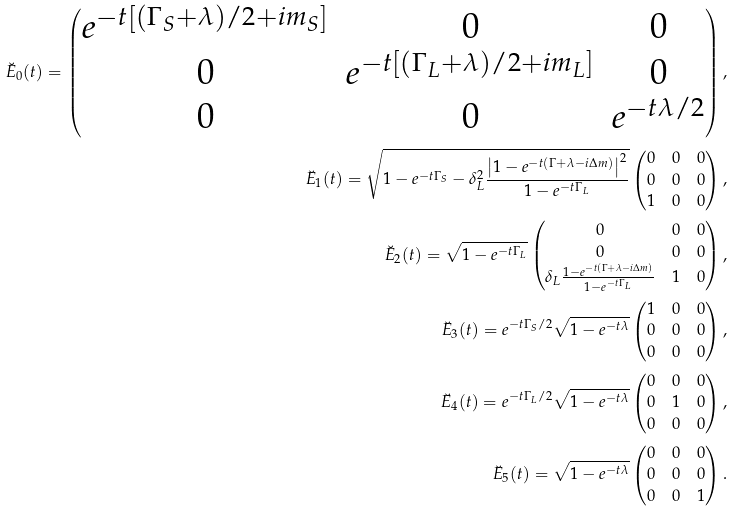Convert formula to latex. <formula><loc_0><loc_0><loc_500><loc_500>\breve { E } _ { 0 } ( t ) = \begin{pmatrix} e ^ { - t \left [ ( \Gamma _ { S } + \lambda ) / 2 + i m _ { S } \right ] } & 0 & 0 \\ 0 & e ^ { - t \left [ ( \Gamma _ { L } + \lambda ) / 2 + i m _ { L } \right ] } & 0 \\ 0 & 0 & e ^ { - t \lambda / 2 } \end{pmatrix} , \\ \breve { E } _ { 1 } ( t ) = \sqrt { 1 - e ^ { - t \Gamma _ { S } } - \delta _ { L } ^ { 2 } \frac { \left | 1 - e ^ { - t ( \Gamma + \lambda - i \Delta m ) } \right | ^ { 2 } } { 1 - e ^ { - t \Gamma _ { L } } } } \begin{pmatrix} 0 & 0 & 0 \\ 0 & 0 & 0 \\ 1 & 0 & 0 \end{pmatrix} , \\ \breve { E } _ { 2 } ( t ) = \sqrt { 1 - e ^ { - t \Gamma _ { L } } } \begin{pmatrix} 0 & 0 & 0 \\ 0 & 0 & 0 \\ \delta _ { L } \frac { 1 - e ^ { - t ( \Gamma + \lambda - i \Delta m ) } } { 1 - e ^ { - t \Gamma _ { L } } } & 1 & 0 \end{pmatrix} , \\ \breve { E } _ { 3 } ( t ) = e ^ { - t \Gamma _ { S } / 2 } \sqrt { 1 - e ^ { - t \lambda } } \begin{pmatrix} 1 & 0 & 0 \\ 0 & 0 & 0 \\ 0 & 0 & 0 \end{pmatrix} , \\ \breve { E } _ { 4 } ( t ) = e ^ { - t \Gamma _ { L } / 2 } \sqrt { 1 - e ^ { - t \lambda } } \begin{pmatrix} 0 & 0 & 0 \\ 0 & 1 & 0 \\ 0 & 0 & 0 \end{pmatrix} , \\ \breve { E } _ { 5 } ( t ) = \sqrt { 1 - e ^ { - t \lambda } } \begin{pmatrix} 0 & 0 & 0 \\ 0 & 0 & 0 \\ 0 & 0 & 1 \end{pmatrix} .</formula> 